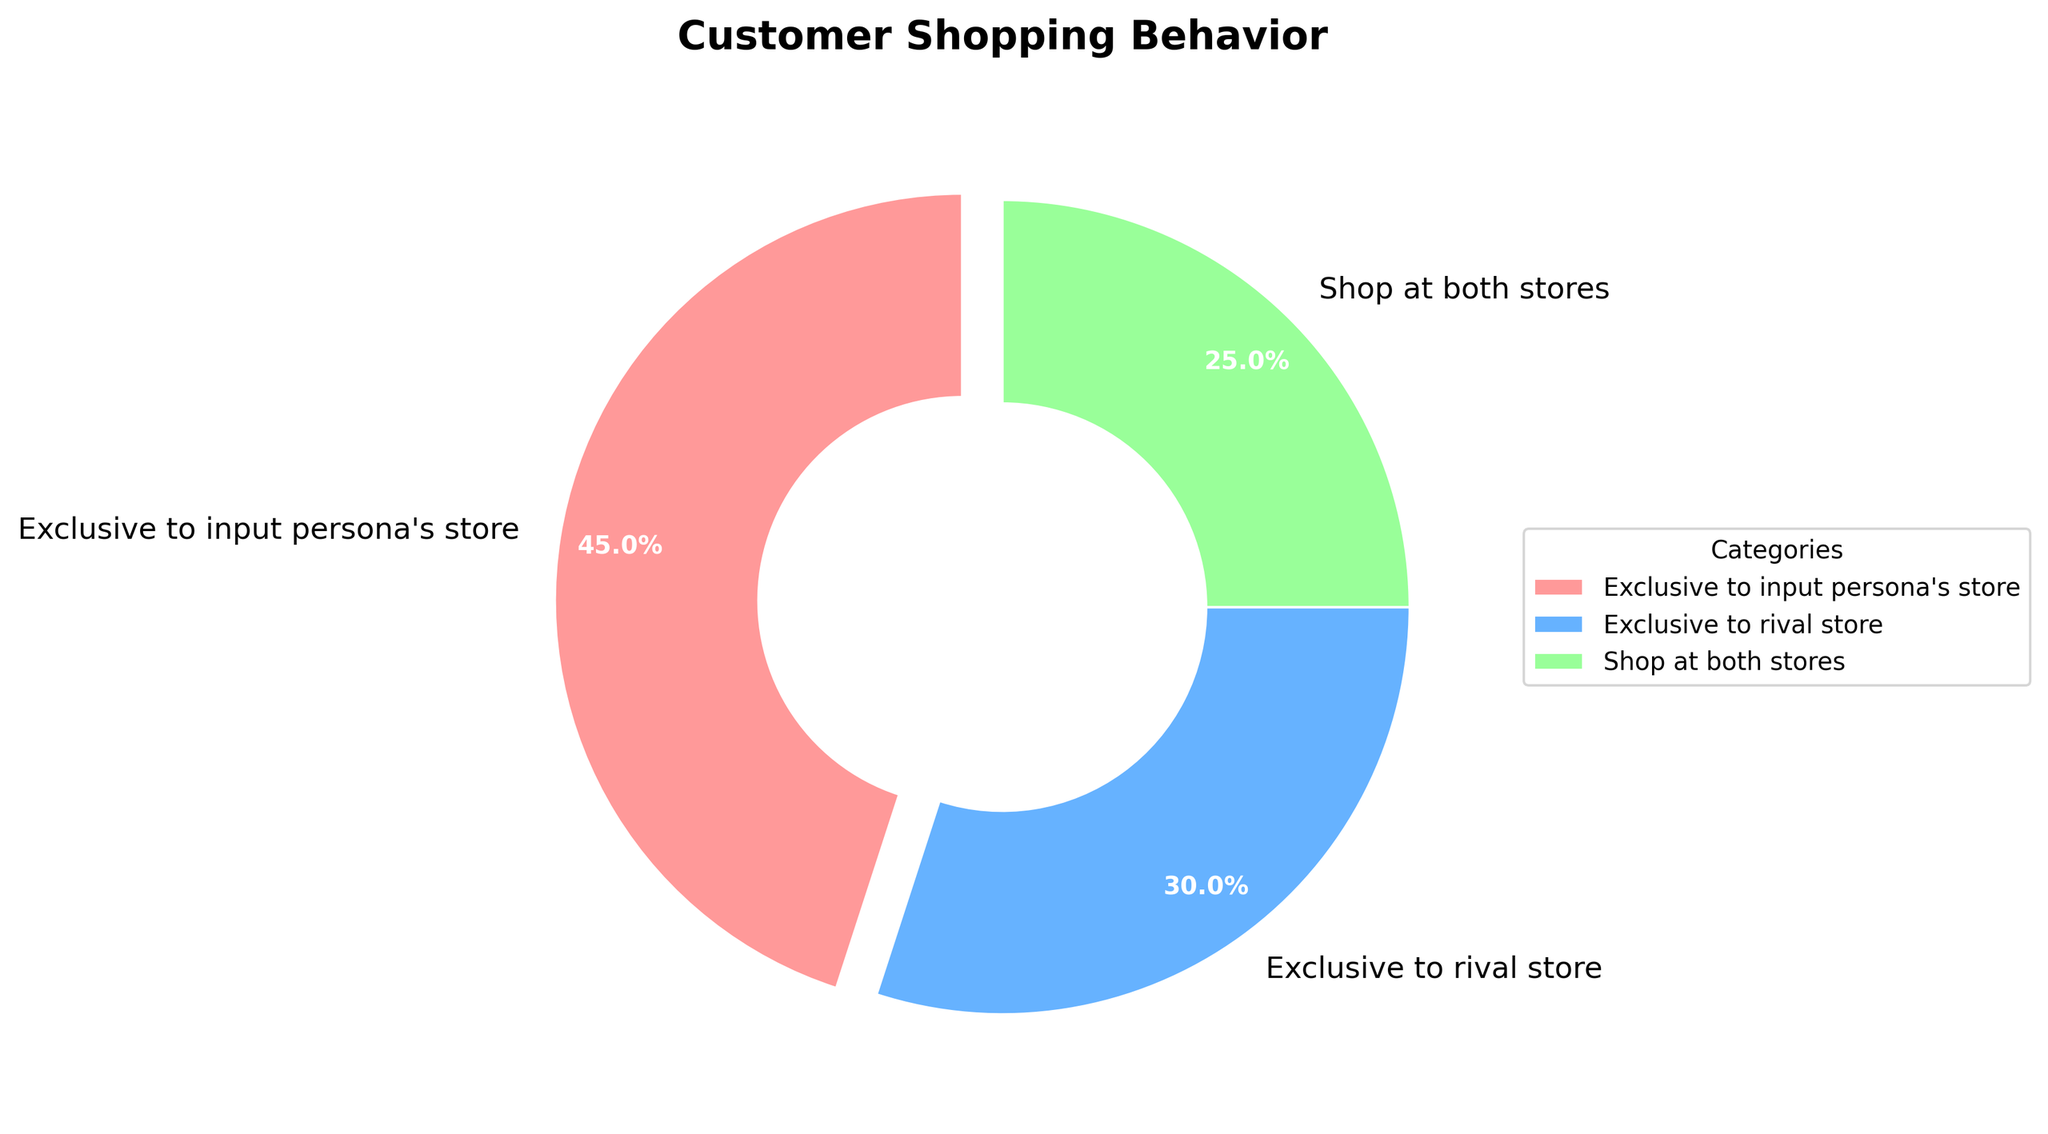What's the percentage of customers exclusive to the input persona's store? The chart shows three categories with their respective percentages. The segment for 'Exclusive to input persona's store' is labeled as 45%.
Answer: 45% How does the percentage of customers exclusive to the rival store compare to those who shop at both stores? The 'Exclusive to rival store' segment is 30%, while the 'Shop at both stores' segment is 25%. Comparing the two, 30% is greater than 25%.
Answer: 30% is greater than 25% What is the combined percentage of customers exclusive to either store? The combined percentage can be determined by adding the percentages of 'Exclusive to input persona's store' and 'Exclusive to rival store'. That is 45% + 30% = 75%.
Answer: 75% Which category has the smallest percentage? Among the three categories, the 'Shop at both stores' segment has the smallest percentage, marked as 25%.
Answer: Shop at both stores If 1000 customers were surveyed, how many would be shopping at both stores? Given that 25% of customers shop at both stores, out of 1000 customers, the number would be 1000 * 0.25 which equals 250.
Answer: 250 What is the difference in percentage points between customers exclusive to input persona's store and those who shop at both stores? The difference can be found by subtracting the percentage of 'Shop at both stores' from 'Exclusive to input persona's store'. That is 45% - 25% = 20%.
Answer: 20% Is the majority of the surveyed customer base exclusive to one store, or do they shop at both? To determine the majority, check if the percentages of 'Exclusive to input persona's store' and 'Exclusive to rival store' combined exceed the 'Shop at both stores'. 45% + 30% = 75%, which is more than 25%. Therefore, the majority shop exclusively at one store.
Answer: Majority shop exclusively at one store 